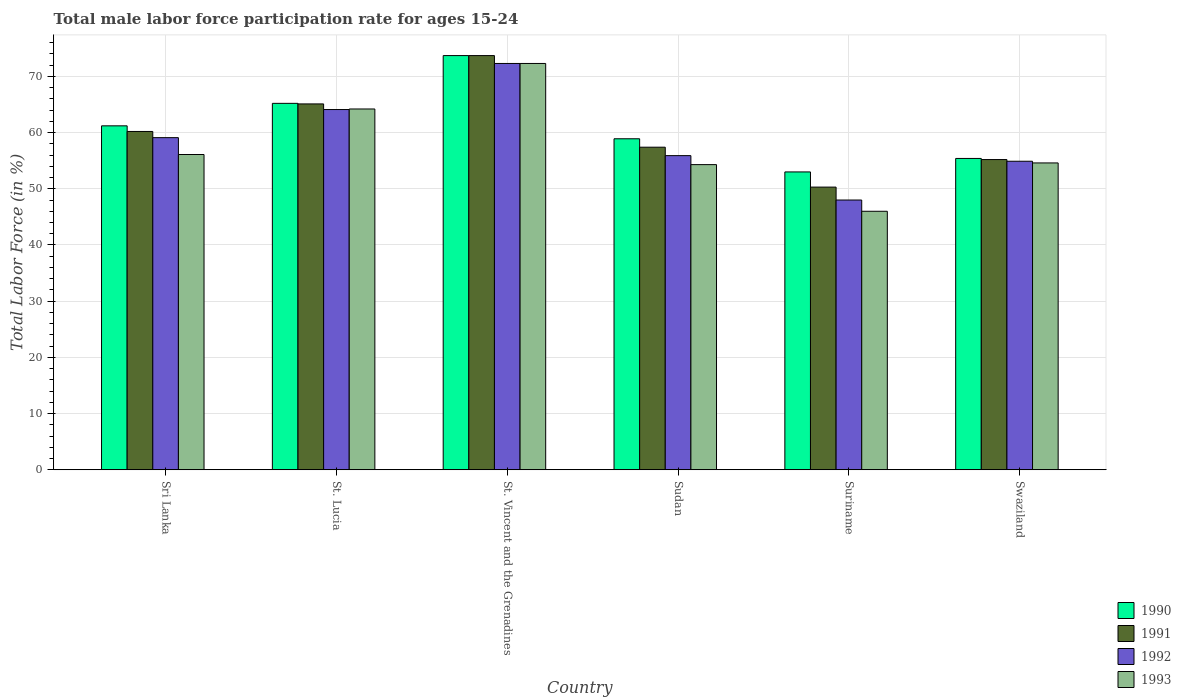How many different coloured bars are there?
Offer a very short reply. 4. How many groups of bars are there?
Offer a very short reply. 6. Are the number of bars per tick equal to the number of legend labels?
Offer a very short reply. Yes. Are the number of bars on each tick of the X-axis equal?
Your answer should be compact. Yes. How many bars are there on the 2nd tick from the left?
Your answer should be compact. 4. What is the label of the 5th group of bars from the left?
Ensure brevity in your answer.  Suriname. What is the male labor force participation rate in 1993 in St. Lucia?
Provide a short and direct response. 64.2. Across all countries, what is the maximum male labor force participation rate in 1990?
Keep it short and to the point. 73.7. In which country was the male labor force participation rate in 1991 maximum?
Give a very brief answer. St. Vincent and the Grenadines. In which country was the male labor force participation rate in 1990 minimum?
Make the answer very short. Suriname. What is the total male labor force participation rate in 1992 in the graph?
Provide a short and direct response. 354.3. What is the difference between the male labor force participation rate in 1992 in St. Lucia and that in Sudan?
Give a very brief answer. 8.2. What is the average male labor force participation rate in 1990 per country?
Ensure brevity in your answer.  61.23. What is the ratio of the male labor force participation rate in 1993 in Suriname to that in Swaziland?
Provide a succinct answer. 0.84. What is the difference between the highest and the second highest male labor force participation rate in 1991?
Your answer should be compact. -8.6. What is the difference between the highest and the lowest male labor force participation rate in 1993?
Give a very brief answer. 26.3. In how many countries, is the male labor force participation rate in 1993 greater than the average male labor force participation rate in 1993 taken over all countries?
Your answer should be very brief. 2. Is the sum of the male labor force participation rate in 1991 in St. Lucia and Swaziland greater than the maximum male labor force participation rate in 1992 across all countries?
Give a very brief answer. Yes. What does the 3rd bar from the right in Sudan represents?
Your answer should be very brief. 1991. Is it the case that in every country, the sum of the male labor force participation rate in 1990 and male labor force participation rate in 1993 is greater than the male labor force participation rate in 1992?
Provide a short and direct response. Yes. How many bars are there?
Offer a terse response. 24. What is the difference between two consecutive major ticks on the Y-axis?
Provide a short and direct response. 10. Are the values on the major ticks of Y-axis written in scientific E-notation?
Your answer should be very brief. No. Does the graph contain any zero values?
Give a very brief answer. No. Does the graph contain grids?
Your answer should be very brief. Yes. What is the title of the graph?
Make the answer very short. Total male labor force participation rate for ages 15-24. What is the label or title of the Y-axis?
Keep it short and to the point. Total Labor Force (in %). What is the Total Labor Force (in %) of 1990 in Sri Lanka?
Provide a short and direct response. 61.2. What is the Total Labor Force (in %) in 1991 in Sri Lanka?
Your answer should be compact. 60.2. What is the Total Labor Force (in %) in 1992 in Sri Lanka?
Offer a very short reply. 59.1. What is the Total Labor Force (in %) of 1993 in Sri Lanka?
Offer a very short reply. 56.1. What is the Total Labor Force (in %) of 1990 in St. Lucia?
Your answer should be compact. 65.2. What is the Total Labor Force (in %) in 1991 in St. Lucia?
Your response must be concise. 65.1. What is the Total Labor Force (in %) in 1992 in St. Lucia?
Your answer should be compact. 64.1. What is the Total Labor Force (in %) in 1993 in St. Lucia?
Give a very brief answer. 64.2. What is the Total Labor Force (in %) in 1990 in St. Vincent and the Grenadines?
Keep it short and to the point. 73.7. What is the Total Labor Force (in %) of 1991 in St. Vincent and the Grenadines?
Your answer should be very brief. 73.7. What is the Total Labor Force (in %) in 1992 in St. Vincent and the Grenadines?
Give a very brief answer. 72.3. What is the Total Labor Force (in %) in 1993 in St. Vincent and the Grenadines?
Your response must be concise. 72.3. What is the Total Labor Force (in %) in 1990 in Sudan?
Provide a short and direct response. 58.9. What is the Total Labor Force (in %) of 1991 in Sudan?
Give a very brief answer. 57.4. What is the Total Labor Force (in %) in 1992 in Sudan?
Give a very brief answer. 55.9. What is the Total Labor Force (in %) in 1993 in Sudan?
Your answer should be very brief. 54.3. What is the Total Labor Force (in %) of 1991 in Suriname?
Provide a short and direct response. 50.3. What is the Total Labor Force (in %) in 1993 in Suriname?
Give a very brief answer. 46. What is the Total Labor Force (in %) of 1990 in Swaziland?
Give a very brief answer. 55.4. What is the Total Labor Force (in %) of 1991 in Swaziland?
Your answer should be very brief. 55.2. What is the Total Labor Force (in %) of 1992 in Swaziland?
Make the answer very short. 54.9. What is the Total Labor Force (in %) in 1993 in Swaziland?
Your answer should be very brief. 54.6. Across all countries, what is the maximum Total Labor Force (in %) in 1990?
Make the answer very short. 73.7. Across all countries, what is the maximum Total Labor Force (in %) of 1991?
Your response must be concise. 73.7. Across all countries, what is the maximum Total Labor Force (in %) of 1992?
Your answer should be very brief. 72.3. Across all countries, what is the maximum Total Labor Force (in %) of 1993?
Give a very brief answer. 72.3. Across all countries, what is the minimum Total Labor Force (in %) of 1991?
Provide a succinct answer. 50.3. Across all countries, what is the minimum Total Labor Force (in %) of 1992?
Give a very brief answer. 48. What is the total Total Labor Force (in %) of 1990 in the graph?
Ensure brevity in your answer.  367.4. What is the total Total Labor Force (in %) of 1991 in the graph?
Ensure brevity in your answer.  361.9. What is the total Total Labor Force (in %) in 1992 in the graph?
Ensure brevity in your answer.  354.3. What is the total Total Labor Force (in %) in 1993 in the graph?
Ensure brevity in your answer.  347.5. What is the difference between the Total Labor Force (in %) of 1990 in Sri Lanka and that in St. Lucia?
Offer a very short reply. -4. What is the difference between the Total Labor Force (in %) in 1993 in Sri Lanka and that in St. Lucia?
Offer a terse response. -8.1. What is the difference between the Total Labor Force (in %) in 1990 in Sri Lanka and that in St. Vincent and the Grenadines?
Your answer should be very brief. -12.5. What is the difference between the Total Labor Force (in %) in 1991 in Sri Lanka and that in St. Vincent and the Grenadines?
Make the answer very short. -13.5. What is the difference between the Total Labor Force (in %) of 1992 in Sri Lanka and that in St. Vincent and the Grenadines?
Give a very brief answer. -13.2. What is the difference between the Total Labor Force (in %) in 1993 in Sri Lanka and that in St. Vincent and the Grenadines?
Your response must be concise. -16.2. What is the difference between the Total Labor Force (in %) of 1992 in Sri Lanka and that in Sudan?
Provide a short and direct response. 3.2. What is the difference between the Total Labor Force (in %) of 1993 in Sri Lanka and that in Sudan?
Ensure brevity in your answer.  1.8. What is the difference between the Total Labor Force (in %) in 1990 in Sri Lanka and that in Suriname?
Your answer should be compact. 8.2. What is the difference between the Total Labor Force (in %) of 1993 in Sri Lanka and that in Suriname?
Provide a short and direct response. 10.1. What is the difference between the Total Labor Force (in %) of 1991 in Sri Lanka and that in Swaziland?
Provide a short and direct response. 5. What is the difference between the Total Labor Force (in %) in 1990 in St. Lucia and that in St. Vincent and the Grenadines?
Make the answer very short. -8.5. What is the difference between the Total Labor Force (in %) in 1993 in St. Lucia and that in St. Vincent and the Grenadines?
Provide a succinct answer. -8.1. What is the difference between the Total Labor Force (in %) in 1992 in St. Lucia and that in Sudan?
Give a very brief answer. 8.2. What is the difference between the Total Labor Force (in %) in 1993 in St. Lucia and that in Sudan?
Provide a short and direct response. 9.9. What is the difference between the Total Labor Force (in %) in 1992 in St. Lucia and that in Suriname?
Your answer should be very brief. 16.1. What is the difference between the Total Labor Force (in %) of 1991 in St. Lucia and that in Swaziland?
Make the answer very short. 9.9. What is the difference between the Total Labor Force (in %) in 1992 in St. Lucia and that in Swaziland?
Offer a very short reply. 9.2. What is the difference between the Total Labor Force (in %) in 1993 in St. Lucia and that in Swaziland?
Provide a short and direct response. 9.6. What is the difference between the Total Labor Force (in %) in 1990 in St. Vincent and the Grenadines and that in Sudan?
Your answer should be compact. 14.8. What is the difference between the Total Labor Force (in %) of 1991 in St. Vincent and the Grenadines and that in Sudan?
Your answer should be compact. 16.3. What is the difference between the Total Labor Force (in %) of 1993 in St. Vincent and the Grenadines and that in Sudan?
Your answer should be compact. 18. What is the difference between the Total Labor Force (in %) in 1990 in St. Vincent and the Grenadines and that in Suriname?
Keep it short and to the point. 20.7. What is the difference between the Total Labor Force (in %) of 1991 in St. Vincent and the Grenadines and that in Suriname?
Your answer should be compact. 23.4. What is the difference between the Total Labor Force (in %) in 1992 in St. Vincent and the Grenadines and that in Suriname?
Make the answer very short. 24.3. What is the difference between the Total Labor Force (in %) in 1993 in St. Vincent and the Grenadines and that in Suriname?
Provide a short and direct response. 26.3. What is the difference between the Total Labor Force (in %) of 1990 in St. Vincent and the Grenadines and that in Swaziland?
Your response must be concise. 18.3. What is the difference between the Total Labor Force (in %) in 1990 in Sudan and that in Swaziland?
Offer a terse response. 3.5. What is the difference between the Total Labor Force (in %) in 1992 in Sudan and that in Swaziland?
Provide a succinct answer. 1. What is the difference between the Total Labor Force (in %) of 1993 in Sudan and that in Swaziland?
Offer a terse response. -0.3. What is the difference between the Total Labor Force (in %) in 1991 in Suriname and that in Swaziland?
Keep it short and to the point. -4.9. What is the difference between the Total Labor Force (in %) in 1990 in Sri Lanka and the Total Labor Force (in %) in 1991 in St. Lucia?
Make the answer very short. -3.9. What is the difference between the Total Labor Force (in %) in 1990 in Sri Lanka and the Total Labor Force (in %) in 1992 in St. Lucia?
Keep it short and to the point. -2.9. What is the difference between the Total Labor Force (in %) in 1990 in Sri Lanka and the Total Labor Force (in %) in 1993 in St. Lucia?
Give a very brief answer. -3. What is the difference between the Total Labor Force (in %) of 1990 in Sri Lanka and the Total Labor Force (in %) of 1991 in St. Vincent and the Grenadines?
Your response must be concise. -12.5. What is the difference between the Total Labor Force (in %) of 1990 in Sri Lanka and the Total Labor Force (in %) of 1993 in St. Vincent and the Grenadines?
Your answer should be very brief. -11.1. What is the difference between the Total Labor Force (in %) of 1991 in Sri Lanka and the Total Labor Force (in %) of 1993 in St. Vincent and the Grenadines?
Offer a very short reply. -12.1. What is the difference between the Total Labor Force (in %) of 1992 in Sri Lanka and the Total Labor Force (in %) of 1993 in St. Vincent and the Grenadines?
Your response must be concise. -13.2. What is the difference between the Total Labor Force (in %) of 1990 in Sri Lanka and the Total Labor Force (in %) of 1991 in Sudan?
Give a very brief answer. 3.8. What is the difference between the Total Labor Force (in %) in 1990 in Sri Lanka and the Total Labor Force (in %) in 1992 in Sudan?
Offer a very short reply. 5.3. What is the difference between the Total Labor Force (in %) of 1991 in Sri Lanka and the Total Labor Force (in %) of 1992 in Sudan?
Your answer should be very brief. 4.3. What is the difference between the Total Labor Force (in %) of 1991 in Sri Lanka and the Total Labor Force (in %) of 1993 in Sudan?
Your response must be concise. 5.9. What is the difference between the Total Labor Force (in %) in 1992 in Sri Lanka and the Total Labor Force (in %) in 1993 in Sudan?
Your answer should be compact. 4.8. What is the difference between the Total Labor Force (in %) of 1990 in Sri Lanka and the Total Labor Force (in %) of 1991 in Suriname?
Keep it short and to the point. 10.9. What is the difference between the Total Labor Force (in %) in 1990 in Sri Lanka and the Total Labor Force (in %) in 1992 in Suriname?
Offer a very short reply. 13.2. What is the difference between the Total Labor Force (in %) in 1990 in Sri Lanka and the Total Labor Force (in %) in 1993 in Suriname?
Give a very brief answer. 15.2. What is the difference between the Total Labor Force (in %) in 1991 in Sri Lanka and the Total Labor Force (in %) in 1992 in Suriname?
Your answer should be very brief. 12.2. What is the difference between the Total Labor Force (in %) in 1991 in Sri Lanka and the Total Labor Force (in %) in 1993 in Suriname?
Ensure brevity in your answer.  14.2. What is the difference between the Total Labor Force (in %) in 1990 in Sri Lanka and the Total Labor Force (in %) in 1991 in Swaziland?
Keep it short and to the point. 6. What is the difference between the Total Labor Force (in %) in 1990 in Sri Lanka and the Total Labor Force (in %) in 1992 in Swaziland?
Offer a very short reply. 6.3. What is the difference between the Total Labor Force (in %) of 1990 in Sri Lanka and the Total Labor Force (in %) of 1993 in Swaziland?
Keep it short and to the point. 6.6. What is the difference between the Total Labor Force (in %) in 1991 in Sri Lanka and the Total Labor Force (in %) in 1993 in Swaziland?
Your response must be concise. 5.6. What is the difference between the Total Labor Force (in %) in 1990 in St. Lucia and the Total Labor Force (in %) in 1993 in St. Vincent and the Grenadines?
Offer a very short reply. -7.1. What is the difference between the Total Labor Force (in %) in 1991 in St. Lucia and the Total Labor Force (in %) in 1993 in St. Vincent and the Grenadines?
Keep it short and to the point. -7.2. What is the difference between the Total Labor Force (in %) in 1992 in St. Lucia and the Total Labor Force (in %) in 1993 in Sudan?
Provide a short and direct response. 9.8. What is the difference between the Total Labor Force (in %) in 1990 in St. Lucia and the Total Labor Force (in %) in 1991 in Suriname?
Your answer should be very brief. 14.9. What is the difference between the Total Labor Force (in %) in 1990 in St. Lucia and the Total Labor Force (in %) in 1993 in Suriname?
Your response must be concise. 19.2. What is the difference between the Total Labor Force (in %) of 1992 in St. Lucia and the Total Labor Force (in %) of 1993 in Suriname?
Your answer should be compact. 18.1. What is the difference between the Total Labor Force (in %) of 1990 in St. Lucia and the Total Labor Force (in %) of 1991 in Swaziland?
Ensure brevity in your answer.  10. What is the difference between the Total Labor Force (in %) of 1990 in St. Lucia and the Total Labor Force (in %) of 1992 in Swaziland?
Give a very brief answer. 10.3. What is the difference between the Total Labor Force (in %) in 1990 in St. Lucia and the Total Labor Force (in %) in 1993 in Swaziland?
Your answer should be very brief. 10.6. What is the difference between the Total Labor Force (in %) of 1991 in St. Lucia and the Total Labor Force (in %) of 1992 in Swaziland?
Provide a short and direct response. 10.2. What is the difference between the Total Labor Force (in %) of 1991 in St. Lucia and the Total Labor Force (in %) of 1993 in Swaziland?
Keep it short and to the point. 10.5. What is the difference between the Total Labor Force (in %) in 1990 in St. Vincent and the Grenadines and the Total Labor Force (in %) in 1991 in Sudan?
Offer a very short reply. 16.3. What is the difference between the Total Labor Force (in %) of 1990 in St. Vincent and the Grenadines and the Total Labor Force (in %) of 1993 in Sudan?
Give a very brief answer. 19.4. What is the difference between the Total Labor Force (in %) in 1991 in St. Vincent and the Grenadines and the Total Labor Force (in %) in 1992 in Sudan?
Provide a succinct answer. 17.8. What is the difference between the Total Labor Force (in %) of 1992 in St. Vincent and the Grenadines and the Total Labor Force (in %) of 1993 in Sudan?
Provide a short and direct response. 18. What is the difference between the Total Labor Force (in %) of 1990 in St. Vincent and the Grenadines and the Total Labor Force (in %) of 1991 in Suriname?
Your answer should be compact. 23.4. What is the difference between the Total Labor Force (in %) in 1990 in St. Vincent and the Grenadines and the Total Labor Force (in %) in 1992 in Suriname?
Your response must be concise. 25.7. What is the difference between the Total Labor Force (in %) of 1990 in St. Vincent and the Grenadines and the Total Labor Force (in %) of 1993 in Suriname?
Your response must be concise. 27.7. What is the difference between the Total Labor Force (in %) of 1991 in St. Vincent and the Grenadines and the Total Labor Force (in %) of 1992 in Suriname?
Your answer should be compact. 25.7. What is the difference between the Total Labor Force (in %) in 1991 in St. Vincent and the Grenadines and the Total Labor Force (in %) in 1993 in Suriname?
Ensure brevity in your answer.  27.7. What is the difference between the Total Labor Force (in %) in 1992 in St. Vincent and the Grenadines and the Total Labor Force (in %) in 1993 in Suriname?
Provide a short and direct response. 26.3. What is the difference between the Total Labor Force (in %) in 1990 in St. Vincent and the Grenadines and the Total Labor Force (in %) in 1992 in Swaziland?
Offer a terse response. 18.8. What is the difference between the Total Labor Force (in %) of 1990 in St. Vincent and the Grenadines and the Total Labor Force (in %) of 1993 in Swaziland?
Offer a terse response. 19.1. What is the difference between the Total Labor Force (in %) of 1990 in Sudan and the Total Labor Force (in %) of 1991 in Suriname?
Provide a succinct answer. 8.6. What is the difference between the Total Labor Force (in %) in 1990 in Sudan and the Total Labor Force (in %) in 1993 in Suriname?
Your answer should be compact. 12.9. What is the difference between the Total Labor Force (in %) in 1992 in Sudan and the Total Labor Force (in %) in 1993 in Suriname?
Your answer should be compact. 9.9. What is the difference between the Total Labor Force (in %) of 1990 in Sudan and the Total Labor Force (in %) of 1992 in Swaziland?
Your answer should be compact. 4. What is the difference between the Total Labor Force (in %) of 1991 in Sudan and the Total Labor Force (in %) of 1992 in Swaziland?
Make the answer very short. 2.5. What is the difference between the Total Labor Force (in %) in 1990 in Suriname and the Total Labor Force (in %) in 1991 in Swaziland?
Your response must be concise. -2.2. What is the difference between the Total Labor Force (in %) of 1990 in Suriname and the Total Labor Force (in %) of 1993 in Swaziland?
Provide a succinct answer. -1.6. What is the difference between the Total Labor Force (in %) in 1991 in Suriname and the Total Labor Force (in %) in 1992 in Swaziland?
Provide a short and direct response. -4.6. What is the difference between the Total Labor Force (in %) in 1992 in Suriname and the Total Labor Force (in %) in 1993 in Swaziland?
Give a very brief answer. -6.6. What is the average Total Labor Force (in %) in 1990 per country?
Provide a short and direct response. 61.23. What is the average Total Labor Force (in %) of 1991 per country?
Offer a terse response. 60.32. What is the average Total Labor Force (in %) of 1992 per country?
Provide a short and direct response. 59.05. What is the average Total Labor Force (in %) in 1993 per country?
Give a very brief answer. 57.92. What is the difference between the Total Labor Force (in %) of 1991 and Total Labor Force (in %) of 1993 in Sri Lanka?
Your answer should be very brief. 4.1. What is the difference between the Total Labor Force (in %) in 1992 and Total Labor Force (in %) in 1993 in Sri Lanka?
Keep it short and to the point. 3. What is the difference between the Total Labor Force (in %) in 1990 and Total Labor Force (in %) in 1992 in St. Lucia?
Offer a very short reply. 1.1. What is the difference between the Total Labor Force (in %) of 1990 and Total Labor Force (in %) of 1993 in St. Lucia?
Offer a very short reply. 1. What is the difference between the Total Labor Force (in %) of 1991 and Total Labor Force (in %) of 1992 in St. Lucia?
Make the answer very short. 1. What is the difference between the Total Labor Force (in %) of 1991 and Total Labor Force (in %) of 1993 in St. Lucia?
Your response must be concise. 0.9. What is the difference between the Total Labor Force (in %) of 1990 and Total Labor Force (in %) of 1991 in St. Vincent and the Grenadines?
Your answer should be very brief. 0. What is the difference between the Total Labor Force (in %) of 1991 and Total Labor Force (in %) of 1993 in St. Vincent and the Grenadines?
Your answer should be very brief. 1.4. What is the difference between the Total Labor Force (in %) of 1990 and Total Labor Force (in %) of 1992 in Sudan?
Provide a succinct answer. 3. What is the difference between the Total Labor Force (in %) of 1990 and Total Labor Force (in %) of 1993 in Sudan?
Make the answer very short. 4.6. What is the difference between the Total Labor Force (in %) of 1991 and Total Labor Force (in %) of 1992 in Sudan?
Your answer should be very brief. 1.5. What is the difference between the Total Labor Force (in %) of 1992 and Total Labor Force (in %) of 1993 in Sudan?
Make the answer very short. 1.6. What is the difference between the Total Labor Force (in %) in 1991 and Total Labor Force (in %) in 1993 in Suriname?
Give a very brief answer. 4.3. What is the difference between the Total Labor Force (in %) in 1991 and Total Labor Force (in %) in 1993 in Swaziland?
Ensure brevity in your answer.  0.6. What is the difference between the Total Labor Force (in %) in 1992 and Total Labor Force (in %) in 1993 in Swaziland?
Ensure brevity in your answer.  0.3. What is the ratio of the Total Labor Force (in %) of 1990 in Sri Lanka to that in St. Lucia?
Make the answer very short. 0.94. What is the ratio of the Total Labor Force (in %) of 1991 in Sri Lanka to that in St. Lucia?
Offer a very short reply. 0.92. What is the ratio of the Total Labor Force (in %) of 1992 in Sri Lanka to that in St. Lucia?
Offer a terse response. 0.92. What is the ratio of the Total Labor Force (in %) of 1993 in Sri Lanka to that in St. Lucia?
Offer a terse response. 0.87. What is the ratio of the Total Labor Force (in %) in 1990 in Sri Lanka to that in St. Vincent and the Grenadines?
Offer a terse response. 0.83. What is the ratio of the Total Labor Force (in %) of 1991 in Sri Lanka to that in St. Vincent and the Grenadines?
Give a very brief answer. 0.82. What is the ratio of the Total Labor Force (in %) of 1992 in Sri Lanka to that in St. Vincent and the Grenadines?
Give a very brief answer. 0.82. What is the ratio of the Total Labor Force (in %) in 1993 in Sri Lanka to that in St. Vincent and the Grenadines?
Make the answer very short. 0.78. What is the ratio of the Total Labor Force (in %) of 1990 in Sri Lanka to that in Sudan?
Keep it short and to the point. 1.04. What is the ratio of the Total Labor Force (in %) of 1991 in Sri Lanka to that in Sudan?
Offer a terse response. 1.05. What is the ratio of the Total Labor Force (in %) in 1992 in Sri Lanka to that in Sudan?
Provide a short and direct response. 1.06. What is the ratio of the Total Labor Force (in %) of 1993 in Sri Lanka to that in Sudan?
Offer a terse response. 1.03. What is the ratio of the Total Labor Force (in %) in 1990 in Sri Lanka to that in Suriname?
Provide a short and direct response. 1.15. What is the ratio of the Total Labor Force (in %) in 1991 in Sri Lanka to that in Suriname?
Offer a terse response. 1.2. What is the ratio of the Total Labor Force (in %) of 1992 in Sri Lanka to that in Suriname?
Offer a very short reply. 1.23. What is the ratio of the Total Labor Force (in %) in 1993 in Sri Lanka to that in Suriname?
Keep it short and to the point. 1.22. What is the ratio of the Total Labor Force (in %) of 1990 in Sri Lanka to that in Swaziland?
Keep it short and to the point. 1.1. What is the ratio of the Total Labor Force (in %) in 1991 in Sri Lanka to that in Swaziland?
Keep it short and to the point. 1.09. What is the ratio of the Total Labor Force (in %) in 1992 in Sri Lanka to that in Swaziland?
Ensure brevity in your answer.  1.08. What is the ratio of the Total Labor Force (in %) in 1993 in Sri Lanka to that in Swaziland?
Keep it short and to the point. 1.03. What is the ratio of the Total Labor Force (in %) in 1990 in St. Lucia to that in St. Vincent and the Grenadines?
Your answer should be very brief. 0.88. What is the ratio of the Total Labor Force (in %) of 1991 in St. Lucia to that in St. Vincent and the Grenadines?
Provide a short and direct response. 0.88. What is the ratio of the Total Labor Force (in %) of 1992 in St. Lucia to that in St. Vincent and the Grenadines?
Give a very brief answer. 0.89. What is the ratio of the Total Labor Force (in %) in 1993 in St. Lucia to that in St. Vincent and the Grenadines?
Your answer should be compact. 0.89. What is the ratio of the Total Labor Force (in %) in 1990 in St. Lucia to that in Sudan?
Your response must be concise. 1.11. What is the ratio of the Total Labor Force (in %) in 1991 in St. Lucia to that in Sudan?
Your answer should be very brief. 1.13. What is the ratio of the Total Labor Force (in %) of 1992 in St. Lucia to that in Sudan?
Provide a short and direct response. 1.15. What is the ratio of the Total Labor Force (in %) in 1993 in St. Lucia to that in Sudan?
Offer a very short reply. 1.18. What is the ratio of the Total Labor Force (in %) in 1990 in St. Lucia to that in Suriname?
Your response must be concise. 1.23. What is the ratio of the Total Labor Force (in %) of 1991 in St. Lucia to that in Suriname?
Your answer should be very brief. 1.29. What is the ratio of the Total Labor Force (in %) of 1992 in St. Lucia to that in Suriname?
Provide a succinct answer. 1.34. What is the ratio of the Total Labor Force (in %) of 1993 in St. Lucia to that in Suriname?
Provide a succinct answer. 1.4. What is the ratio of the Total Labor Force (in %) of 1990 in St. Lucia to that in Swaziland?
Make the answer very short. 1.18. What is the ratio of the Total Labor Force (in %) of 1991 in St. Lucia to that in Swaziland?
Offer a very short reply. 1.18. What is the ratio of the Total Labor Force (in %) in 1992 in St. Lucia to that in Swaziland?
Your answer should be very brief. 1.17. What is the ratio of the Total Labor Force (in %) of 1993 in St. Lucia to that in Swaziland?
Your answer should be very brief. 1.18. What is the ratio of the Total Labor Force (in %) in 1990 in St. Vincent and the Grenadines to that in Sudan?
Your answer should be very brief. 1.25. What is the ratio of the Total Labor Force (in %) of 1991 in St. Vincent and the Grenadines to that in Sudan?
Give a very brief answer. 1.28. What is the ratio of the Total Labor Force (in %) in 1992 in St. Vincent and the Grenadines to that in Sudan?
Offer a terse response. 1.29. What is the ratio of the Total Labor Force (in %) in 1993 in St. Vincent and the Grenadines to that in Sudan?
Your answer should be very brief. 1.33. What is the ratio of the Total Labor Force (in %) in 1990 in St. Vincent and the Grenadines to that in Suriname?
Keep it short and to the point. 1.39. What is the ratio of the Total Labor Force (in %) in 1991 in St. Vincent and the Grenadines to that in Suriname?
Your answer should be compact. 1.47. What is the ratio of the Total Labor Force (in %) in 1992 in St. Vincent and the Grenadines to that in Suriname?
Provide a short and direct response. 1.51. What is the ratio of the Total Labor Force (in %) in 1993 in St. Vincent and the Grenadines to that in Suriname?
Ensure brevity in your answer.  1.57. What is the ratio of the Total Labor Force (in %) of 1990 in St. Vincent and the Grenadines to that in Swaziland?
Ensure brevity in your answer.  1.33. What is the ratio of the Total Labor Force (in %) in 1991 in St. Vincent and the Grenadines to that in Swaziland?
Provide a short and direct response. 1.34. What is the ratio of the Total Labor Force (in %) of 1992 in St. Vincent and the Grenadines to that in Swaziland?
Your answer should be compact. 1.32. What is the ratio of the Total Labor Force (in %) in 1993 in St. Vincent and the Grenadines to that in Swaziland?
Offer a very short reply. 1.32. What is the ratio of the Total Labor Force (in %) of 1990 in Sudan to that in Suriname?
Offer a very short reply. 1.11. What is the ratio of the Total Labor Force (in %) of 1991 in Sudan to that in Suriname?
Your answer should be compact. 1.14. What is the ratio of the Total Labor Force (in %) of 1992 in Sudan to that in Suriname?
Provide a succinct answer. 1.16. What is the ratio of the Total Labor Force (in %) in 1993 in Sudan to that in Suriname?
Ensure brevity in your answer.  1.18. What is the ratio of the Total Labor Force (in %) in 1990 in Sudan to that in Swaziland?
Ensure brevity in your answer.  1.06. What is the ratio of the Total Labor Force (in %) of 1991 in Sudan to that in Swaziland?
Your answer should be very brief. 1.04. What is the ratio of the Total Labor Force (in %) of 1992 in Sudan to that in Swaziland?
Give a very brief answer. 1.02. What is the ratio of the Total Labor Force (in %) in 1990 in Suriname to that in Swaziland?
Keep it short and to the point. 0.96. What is the ratio of the Total Labor Force (in %) in 1991 in Suriname to that in Swaziland?
Your response must be concise. 0.91. What is the ratio of the Total Labor Force (in %) of 1992 in Suriname to that in Swaziland?
Give a very brief answer. 0.87. What is the ratio of the Total Labor Force (in %) in 1993 in Suriname to that in Swaziland?
Offer a terse response. 0.84. What is the difference between the highest and the second highest Total Labor Force (in %) in 1990?
Your answer should be very brief. 8.5. What is the difference between the highest and the second highest Total Labor Force (in %) of 1991?
Make the answer very short. 8.6. What is the difference between the highest and the second highest Total Labor Force (in %) in 1992?
Your response must be concise. 8.2. What is the difference between the highest and the lowest Total Labor Force (in %) of 1990?
Make the answer very short. 20.7. What is the difference between the highest and the lowest Total Labor Force (in %) in 1991?
Your response must be concise. 23.4. What is the difference between the highest and the lowest Total Labor Force (in %) in 1992?
Make the answer very short. 24.3. What is the difference between the highest and the lowest Total Labor Force (in %) of 1993?
Offer a very short reply. 26.3. 